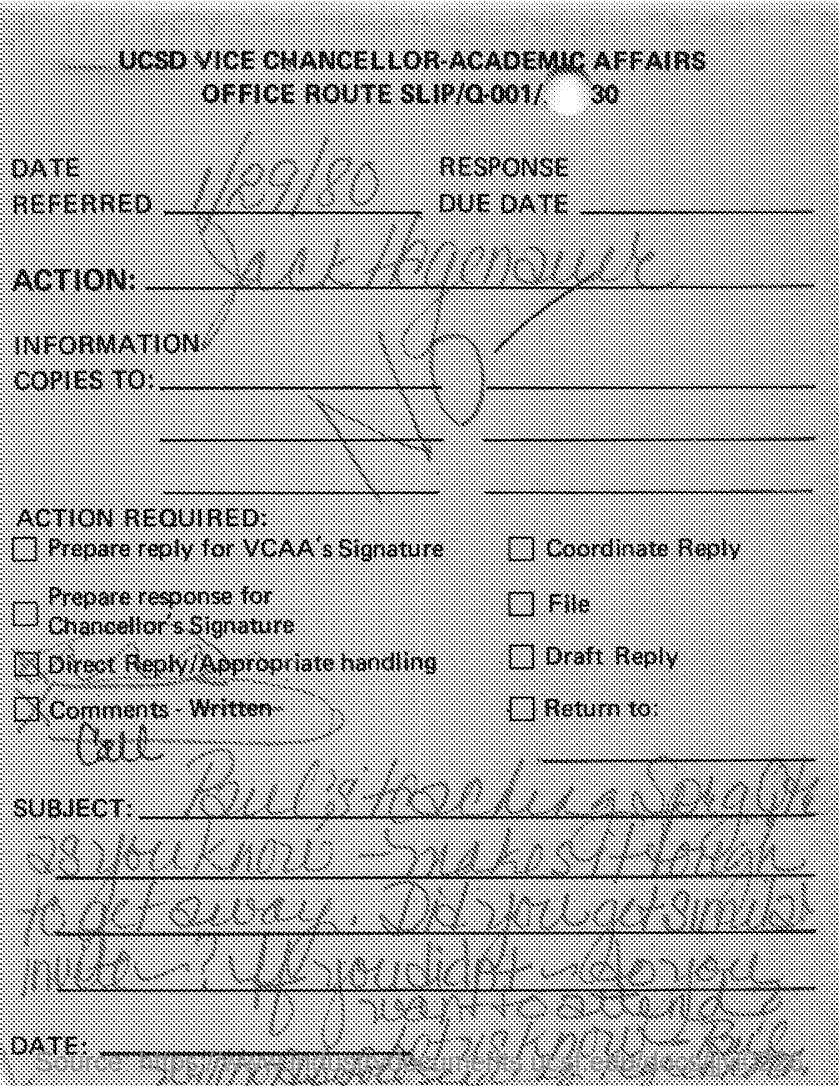What is the date referred as mentioned in the slip ?
Your response must be concise. 1/29/80. 